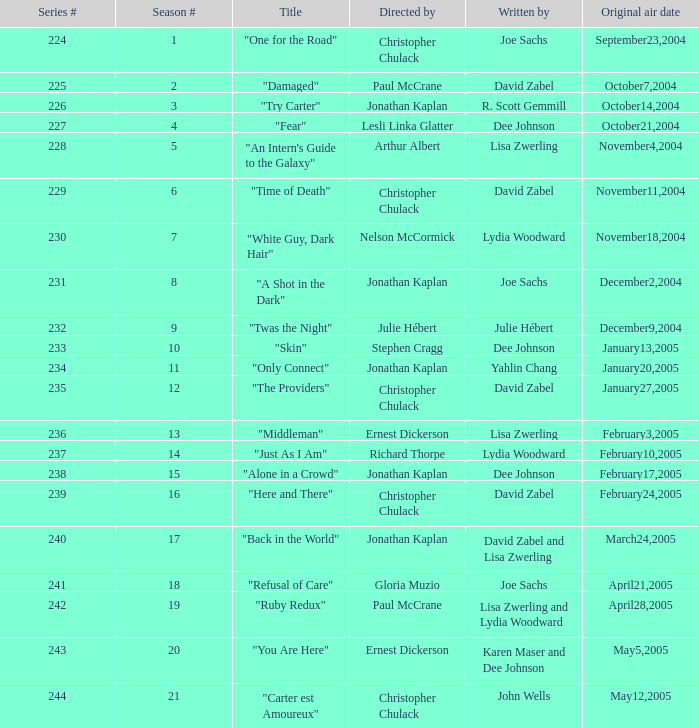Can you identify the title penned by r. scott gemmill? "Try Carter". 